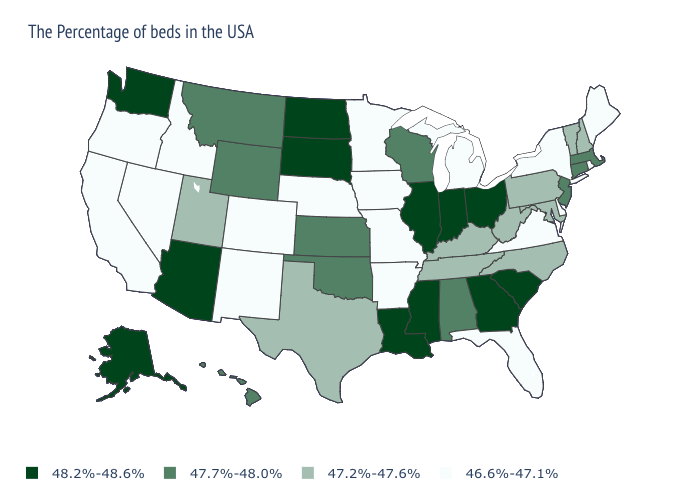Does the first symbol in the legend represent the smallest category?
Be succinct. No. Does Arizona have the highest value in the USA?
Quick response, please. Yes. What is the lowest value in the USA?
Short answer required. 46.6%-47.1%. Which states have the lowest value in the MidWest?
Concise answer only. Michigan, Missouri, Minnesota, Iowa, Nebraska. Name the states that have a value in the range 46.6%-47.1%?
Write a very short answer. Maine, Rhode Island, New York, Delaware, Virginia, Florida, Michigan, Missouri, Arkansas, Minnesota, Iowa, Nebraska, Colorado, New Mexico, Idaho, Nevada, California, Oregon. Name the states that have a value in the range 47.2%-47.6%?
Concise answer only. New Hampshire, Vermont, Maryland, Pennsylvania, North Carolina, West Virginia, Kentucky, Tennessee, Texas, Utah. Name the states that have a value in the range 47.2%-47.6%?
Concise answer only. New Hampshire, Vermont, Maryland, Pennsylvania, North Carolina, West Virginia, Kentucky, Tennessee, Texas, Utah. How many symbols are there in the legend?
Answer briefly. 4. Name the states that have a value in the range 46.6%-47.1%?
Be succinct. Maine, Rhode Island, New York, Delaware, Virginia, Florida, Michigan, Missouri, Arkansas, Minnesota, Iowa, Nebraska, Colorado, New Mexico, Idaho, Nevada, California, Oregon. What is the value of Oklahoma?
Be succinct. 47.7%-48.0%. Is the legend a continuous bar?
Write a very short answer. No. Which states have the lowest value in the West?
Keep it brief. Colorado, New Mexico, Idaho, Nevada, California, Oregon. What is the value of Idaho?
Quick response, please. 46.6%-47.1%. What is the highest value in states that border Mississippi?
Give a very brief answer. 48.2%-48.6%. Name the states that have a value in the range 47.2%-47.6%?
Give a very brief answer. New Hampshire, Vermont, Maryland, Pennsylvania, North Carolina, West Virginia, Kentucky, Tennessee, Texas, Utah. 